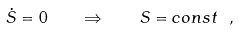<formula> <loc_0><loc_0><loc_500><loc_500>\dot { S } = 0 \quad \Rightarrow \quad S = c o n s t \ ,</formula> 